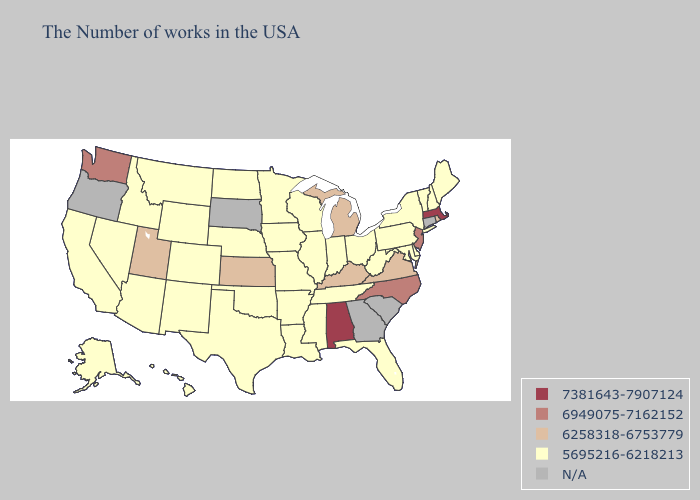Among the states that border Indiana , which have the lowest value?
Quick response, please. Ohio, Illinois. Name the states that have a value in the range 6949075-7162152?
Concise answer only. New Jersey, North Carolina, Washington. What is the lowest value in the West?
Short answer required. 5695216-6218213. What is the lowest value in the USA?
Short answer required. 5695216-6218213. What is the value of Massachusetts?
Keep it brief. 7381643-7907124. Name the states that have a value in the range 7381643-7907124?
Answer briefly. Massachusetts, Alabama. Name the states that have a value in the range 7381643-7907124?
Answer briefly. Massachusetts, Alabama. Name the states that have a value in the range 7381643-7907124?
Concise answer only. Massachusetts, Alabama. Among the states that border Nebraska , does Iowa have the lowest value?
Quick response, please. Yes. Name the states that have a value in the range 5695216-6218213?
Write a very short answer. Maine, New Hampshire, Vermont, New York, Delaware, Maryland, Pennsylvania, West Virginia, Ohio, Florida, Indiana, Tennessee, Wisconsin, Illinois, Mississippi, Louisiana, Missouri, Arkansas, Minnesota, Iowa, Nebraska, Oklahoma, Texas, North Dakota, Wyoming, Colorado, New Mexico, Montana, Arizona, Idaho, Nevada, California, Alaska, Hawaii. Which states have the highest value in the USA?
Short answer required. Massachusetts, Alabama. What is the value of Idaho?
Concise answer only. 5695216-6218213. Does Maine have the highest value in the Northeast?
Give a very brief answer. No. What is the value of Illinois?
Answer briefly. 5695216-6218213. 